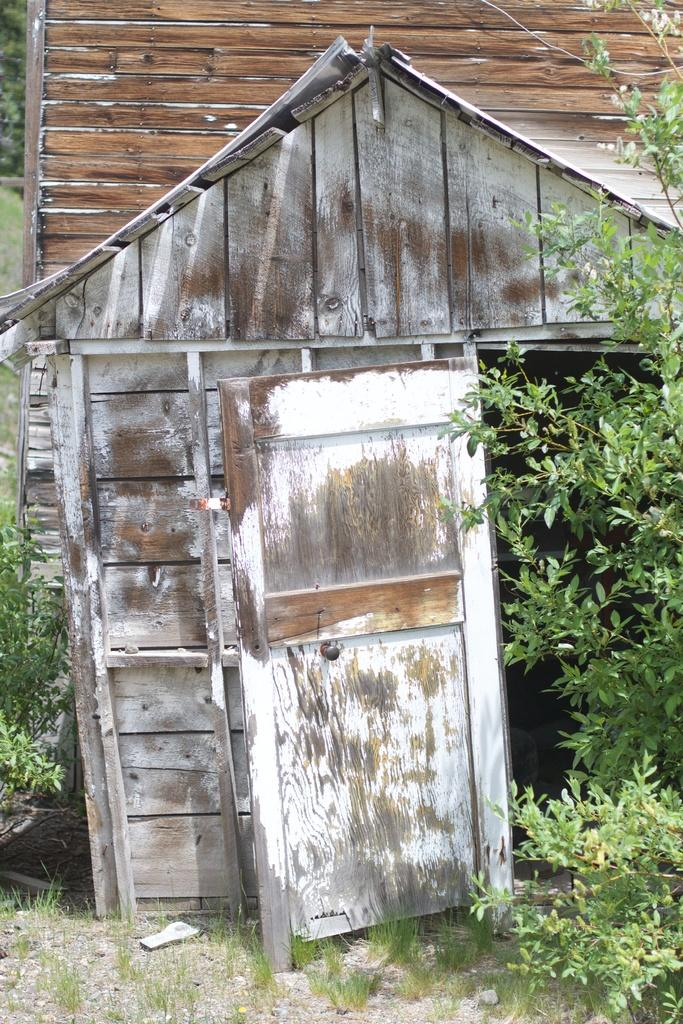What type of house is in the image? There is an old wooden house in the image. What can be seen growing in the image? There are plants in the image. What type of ground cover is near the house? There is grass near the house in the image. Where is the cave located in the image? There is no cave present in the image. What type of stew is being prepared in the image? There is no stew being prepared in the image. 